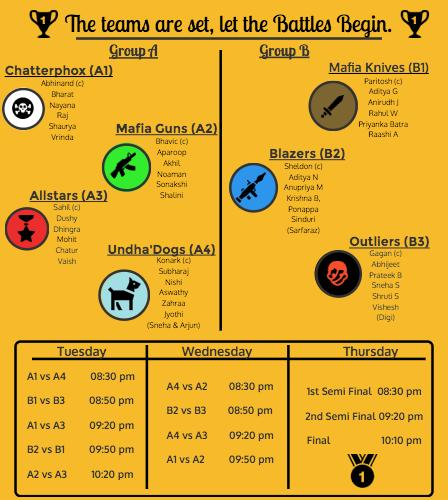Draw attention to some important aspects in this diagram. Undha Dogs' captain is Konark. There are 6 members in Allstars. Sonakshi is a member of the Mafia Guns team. The number written on the medal is 1. The teams A4 and A3 will be competing in the third match, which will take place on Wednesday. 